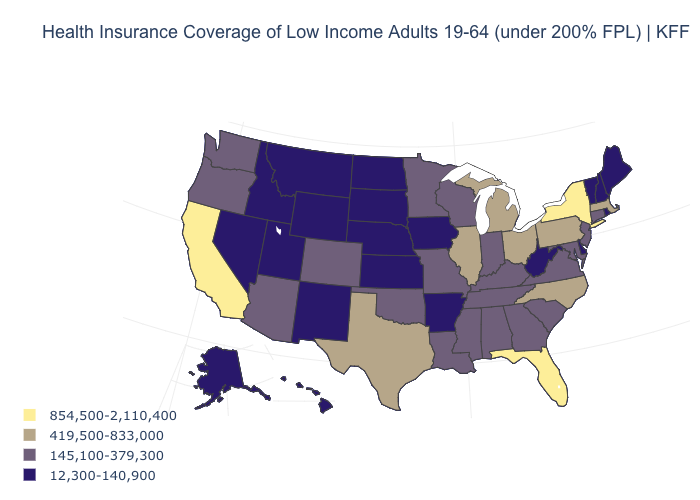Name the states that have a value in the range 145,100-379,300?
Concise answer only. Alabama, Arizona, Colorado, Connecticut, Georgia, Indiana, Kentucky, Louisiana, Maryland, Minnesota, Mississippi, Missouri, New Jersey, Oklahoma, Oregon, South Carolina, Tennessee, Virginia, Washington, Wisconsin. What is the value of New Jersey?
Give a very brief answer. 145,100-379,300. What is the highest value in the South ?
Write a very short answer. 854,500-2,110,400. Name the states that have a value in the range 12,300-140,900?
Keep it brief. Alaska, Arkansas, Delaware, Hawaii, Idaho, Iowa, Kansas, Maine, Montana, Nebraska, Nevada, New Hampshire, New Mexico, North Dakota, Rhode Island, South Dakota, Utah, Vermont, West Virginia, Wyoming. Which states have the lowest value in the USA?
Concise answer only. Alaska, Arkansas, Delaware, Hawaii, Idaho, Iowa, Kansas, Maine, Montana, Nebraska, Nevada, New Hampshire, New Mexico, North Dakota, Rhode Island, South Dakota, Utah, Vermont, West Virginia, Wyoming. Among the states that border Pennsylvania , does New York have the highest value?
Quick response, please. Yes. Does the map have missing data?
Quick response, please. No. Among the states that border Tennessee , which have the lowest value?
Be succinct. Arkansas. Which states hav the highest value in the South?
Keep it brief. Florida. Which states have the lowest value in the South?
Answer briefly. Arkansas, Delaware, West Virginia. Name the states that have a value in the range 854,500-2,110,400?
Answer briefly. California, Florida, New York. Name the states that have a value in the range 854,500-2,110,400?
Write a very short answer. California, Florida, New York. Name the states that have a value in the range 854,500-2,110,400?
Short answer required. California, Florida, New York. Does Georgia have a higher value than Missouri?
Quick response, please. No. What is the value of Iowa?
Answer briefly. 12,300-140,900. 